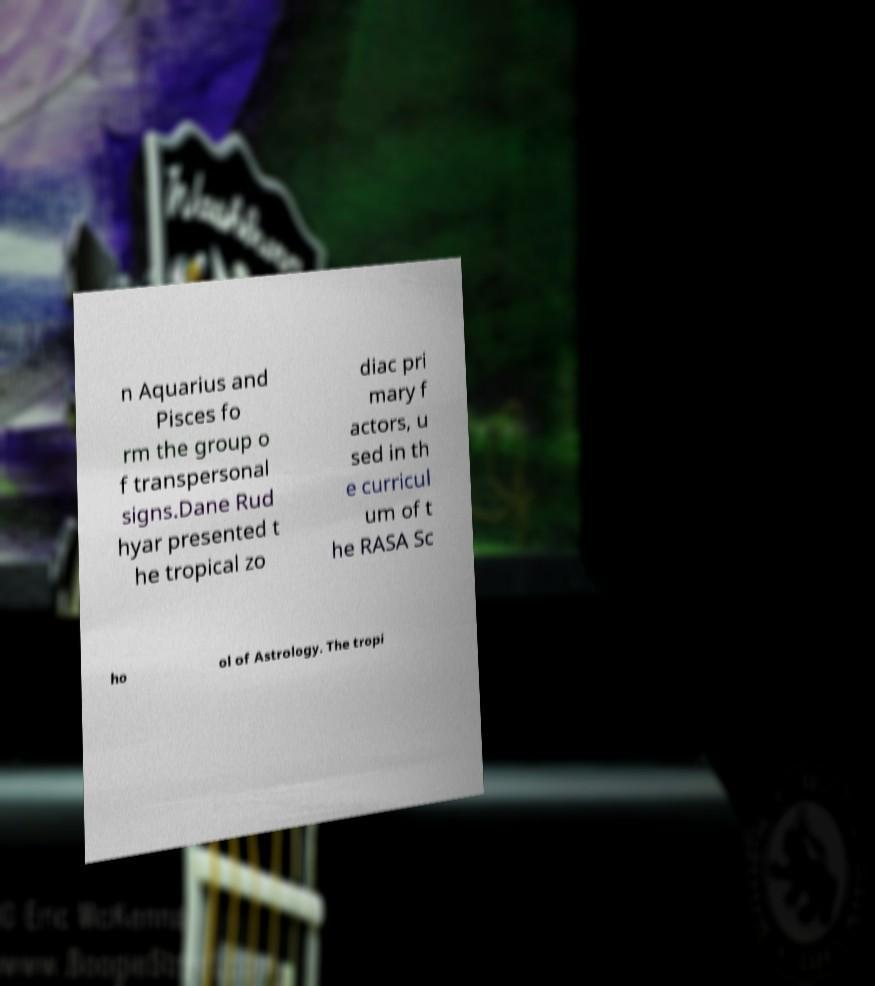Please read and relay the text visible in this image. What does it say? n Aquarius and Pisces fo rm the group o f transpersonal signs.Dane Rud hyar presented t he tropical zo diac pri mary f actors, u sed in th e curricul um of t he RASA Sc ho ol of Astrology. The tropi 